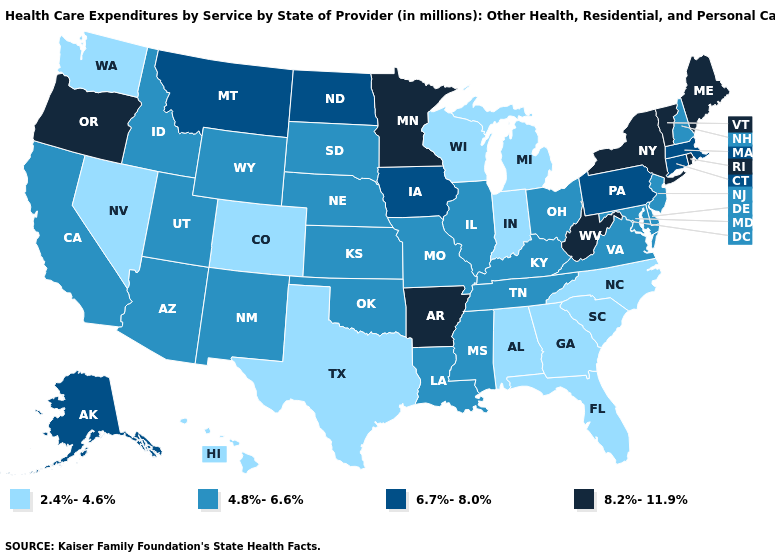Does Minnesota have the highest value in the MidWest?
Give a very brief answer. Yes. Does Vermont have a higher value than Rhode Island?
Concise answer only. No. Which states have the highest value in the USA?
Quick response, please. Arkansas, Maine, Minnesota, New York, Oregon, Rhode Island, Vermont, West Virginia. Name the states that have a value in the range 8.2%-11.9%?
Keep it brief. Arkansas, Maine, Minnesota, New York, Oregon, Rhode Island, Vermont, West Virginia. Does the first symbol in the legend represent the smallest category?
Short answer required. Yes. What is the value of Iowa?
Write a very short answer. 6.7%-8.0%. Name the states that have a value in the range 2.4%-4.6%?
Be succinct. Alabama, Colorado, Florida, Georgia, Hawaii, Indiana, Michigan, Nevada, North Carolina, South Carolina, Texas, Washington, Wisconsin. Does North Carolina have the lowest value in the USA?
Quick response, please. Yes. Name the states that have a value in the range 6.7%-8.0%?
Be succinct. Alaska, Connecticut, Iowa, Massachusetts, Montana, North Dakota, Pennsylvania. What is the value of Georgia?
Answer briefly. 2.4%-4.6%. Which states have the lowest value in the USA?
Quick response, please. Alabama, Colorado, Florida, Georgia, Hawaii, Indiana, Michigan, Nevada, North Carolina, South Carolina, Texas, Washington, Wisconsin. What is the value of New Jersey?
Be succinct. 4.8%-6.6%. What is the lowest value in the USA?
Keep it brief. 2.4%-4.6%. What is the lowest value in states that border Mississippi?
Write a very short answer. 2.4%-4.6%. Which states hav the highest value in the South?
Short answer required. Arkansas, West Virginia. 